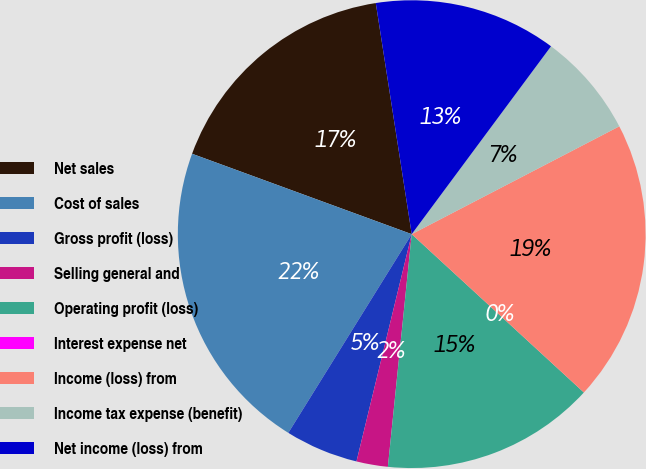<chart> <loc_0><loc_0><loc_500><loc_500><pie_chart><fcel>Net sales<fcel>Cost of sales<fcel>Gross profit (loss)<fcel>Selling general and<fcel>Operating profit (loss)<fcel>Interest expense net<fcel>Income (loss) from<fcel>Income tax expense (benefit)<fcel>Net income (loss) from<nl><fcel>16.96%<fcel>21.74%<fcel>5.05%<fcel>2.17%<fcel>14.79%<fcel>0.0%<fcel>19.46%<fcel>7.22%<fcel>12.61%<nl></chart> 